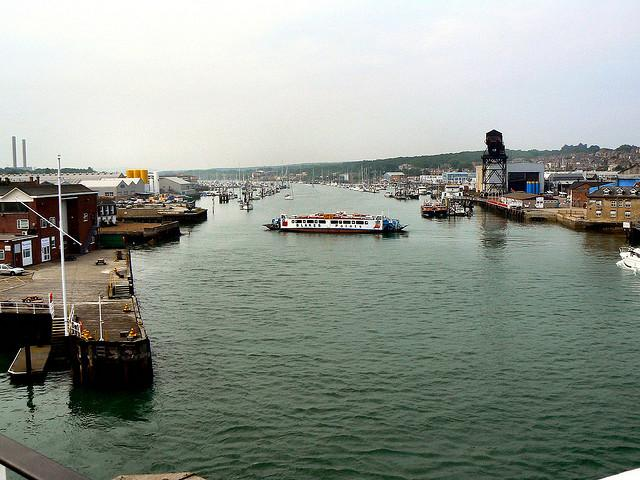What color are the end bridges for the boat suspended in the middle of the river? Please explain your reasoning. blue. The ends of the boat are colored blue in the middle of the river. 